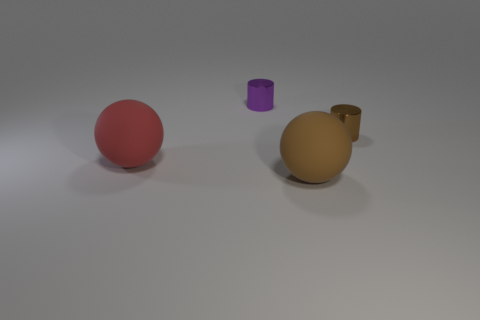Subtract all red balls. How many purple cylinders are left? 1 Add 2 green metallic things. How many objects exist? 6 Subtract 1 spheres. How many spheres are left? 1 Subtract all green cylinders. Subtract all cyan spheres. How many cylinders are left? 2 Subtract all cylinders. Subtract all small metallic cubes. How many objects are left? 2 Add 4 purple metallic objects. How many purple metallic objects are left? 5 Add 4 large red spheres. How many large red spheres exist? 5 Subtract 0 blue cubes. How many objects are left? 4 